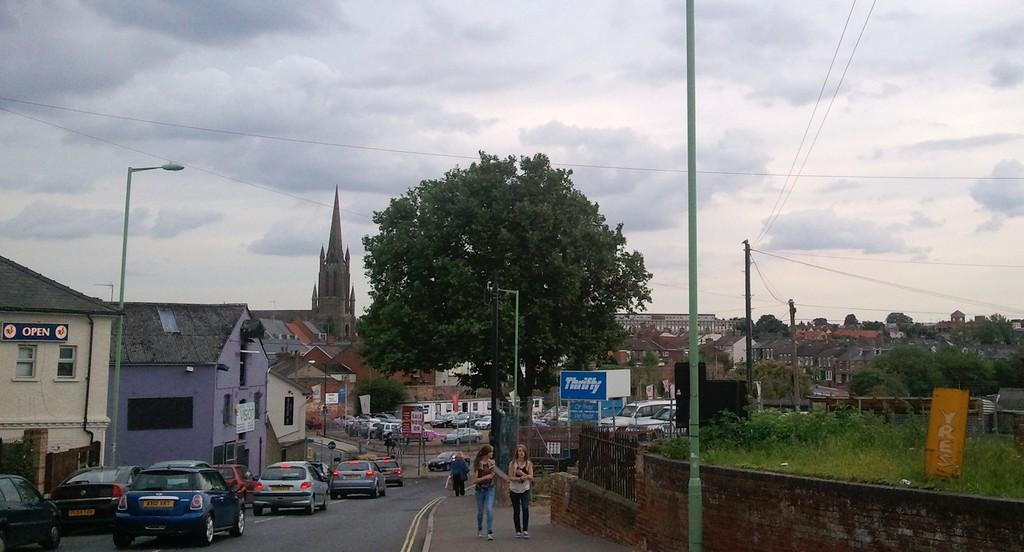What types of objects can be seen in the image? There are vehicles, poles, and posters at the bottom side of the image. Are there any living beings present in the image? Yes, there are people in the image. What is the landscape like in the image? The image features grassland, trees, and houses in the background. What else can be seen in the background of the image? There are wires and the sky visible in the background. What type of bait is being used by the people in the image? There is no indication of fishing or bait in the image; it features vehicles, poles, people, grassland, posters, houses, trees, wires, and the sky. What is the purpose of the wool in the image? There is no wool present in the image. 